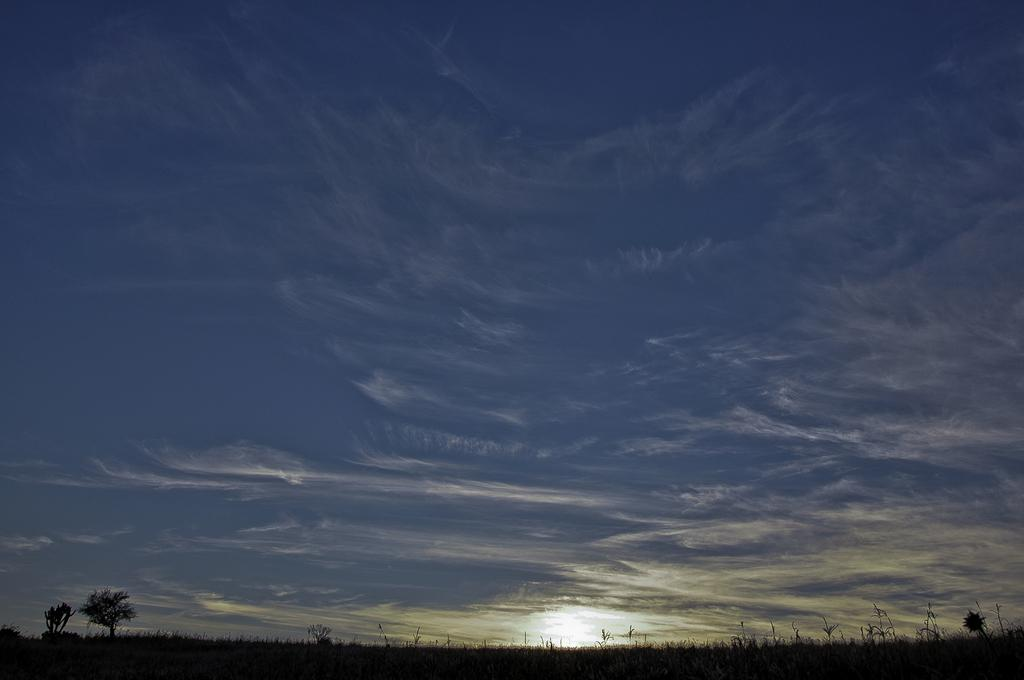Where was the image taken? The image was clicked outside the city. What can be seen in the foreground of the image? There are trees and other objects in the foreground of the image. What is visible in the background of the image? The sky is visible in the background of the image. What historical event is being commemorated in the image? There is no historical event being commemorated in the image; it features trees, other objects, and the sky. What is the profit margin of the objects in the foreground? There is no profit margin associated with the objects in the foreground, as they are not being sold or traded. 